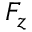<formula> <loc_0><loc_0><loc_500><loc_500>F _ { z }</formula> 